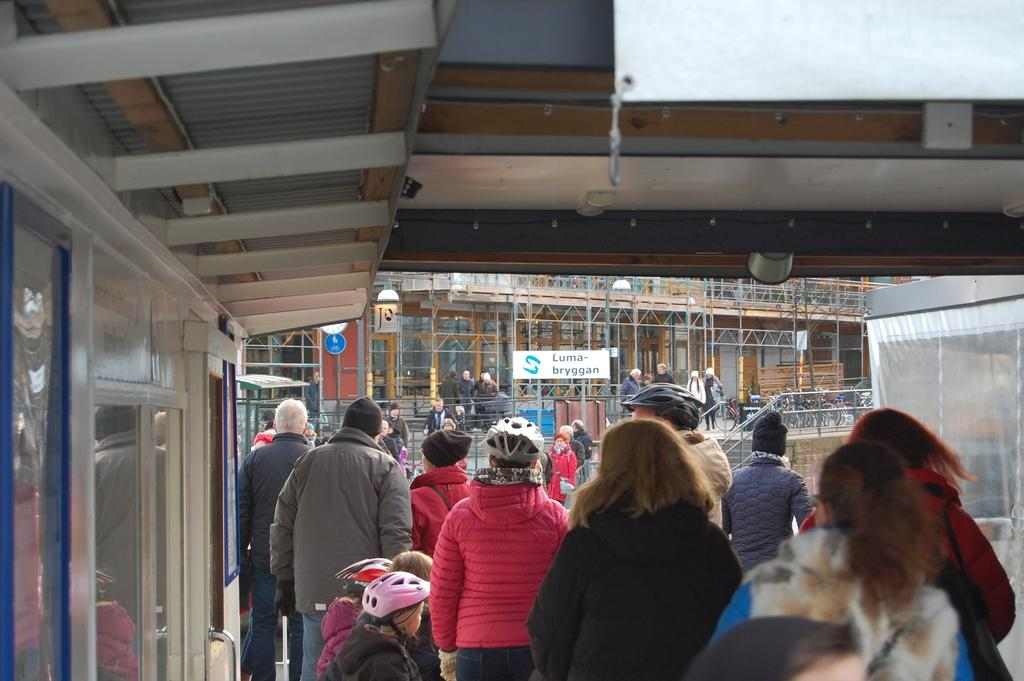How many people are in the image? There is a group of people in the image. What are some of the people wearing? Some of the people are wearing helmets. What can be seen in the background of the image? There are buildings, boards, poles, and other objects in the background of the image. How many donkeys are present in the image? There are no donkeys present in the image. What type of men can be seen interacting with the market in the image? There is no market or men interacting with a market present in the image. 